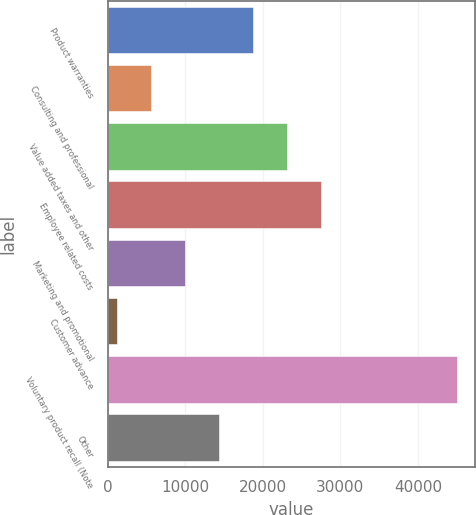Convert chart. <chart><loc_0><loc_0><loc_500><loc_500><bar_chart><fcel>Product warranties<fcel>Consulting and professional<fcel>Value added taxes and other<fcel>Employee related costs<fcel>Marketing and promotional<fcel>Customer advance<fcel>Voluntary product recall (Note<fcel>Other<nl><fcel>18740<fcel>5561<fcel>23133<fcel>27526<fcel>9954<fcel>1168<fcel>45098<fcel>14347<nl></chart> 